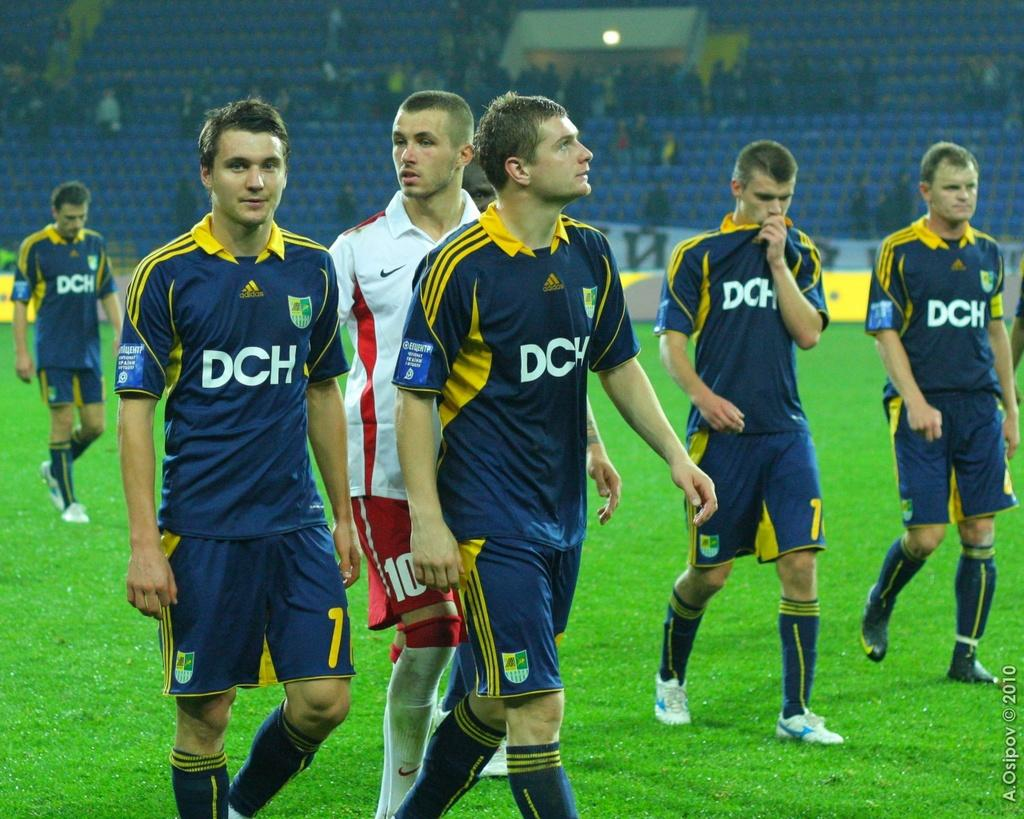Provide a one-sentence caption for the provided image. Several soccer players are wearing blue jerseys with the letters DCH printed on the chest. 